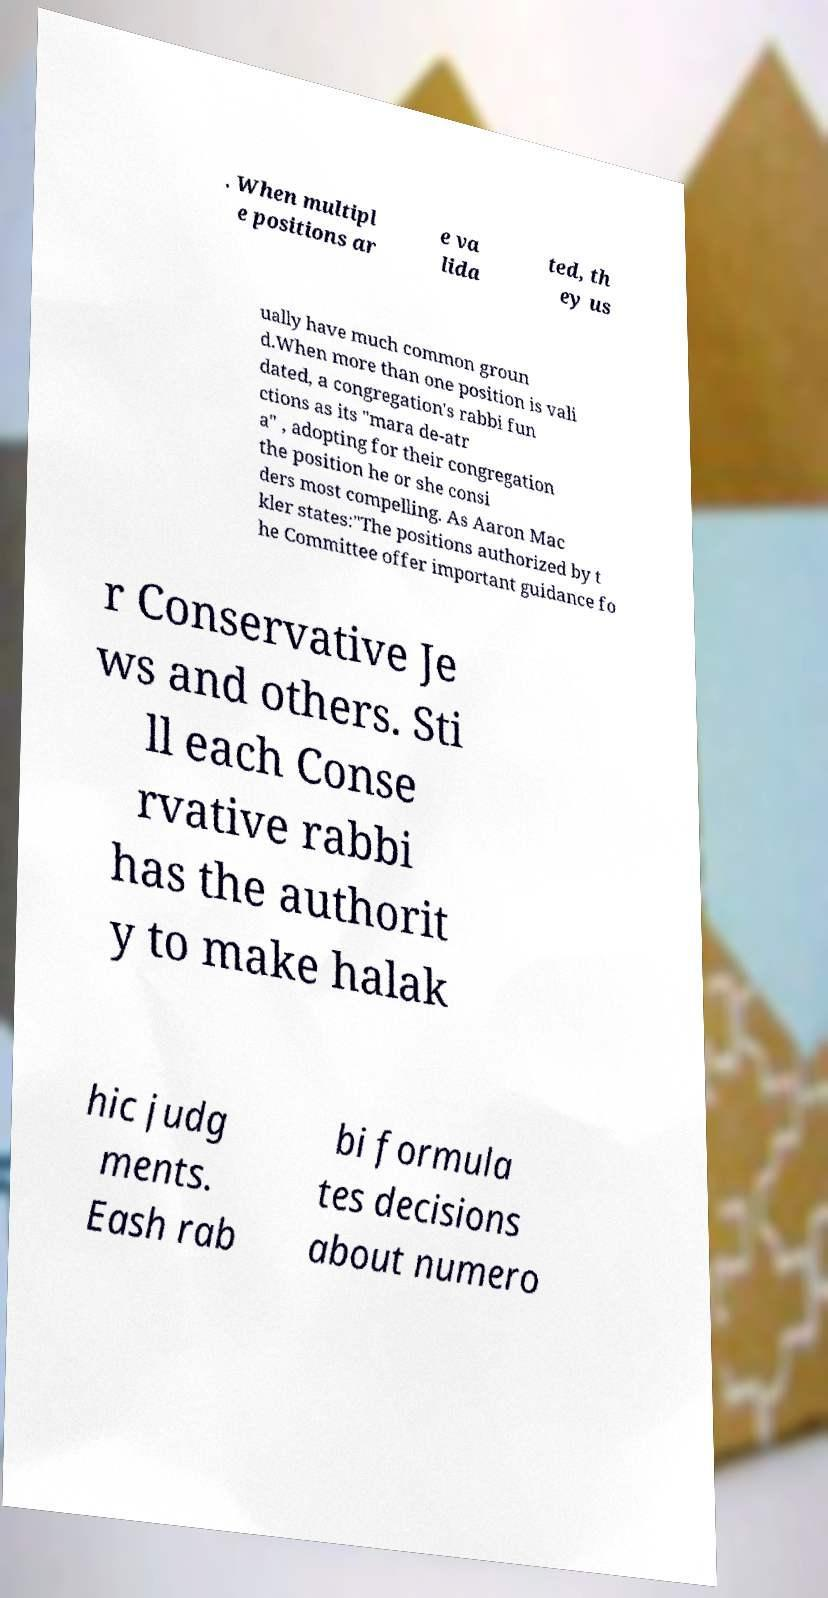Please identify and transcribe the text found in this image. . When multipl e positions ar e va lida ted, th ey us ually have much common groun d.When more than one position is vali dated, a congregation's rabbi fun ctions as its "mara de-atr a" , adopting for their congregation the position he or she consi ders most compelling. As Aaron Mac kler states:"The positions authorized by t he Committee offer important guidance fo r Conservative Je ws and others. Sti ll each Conse rvative rabbi has the authorit y to make halak hic judg ments. Eash rab bi formula tes decisions about numero 